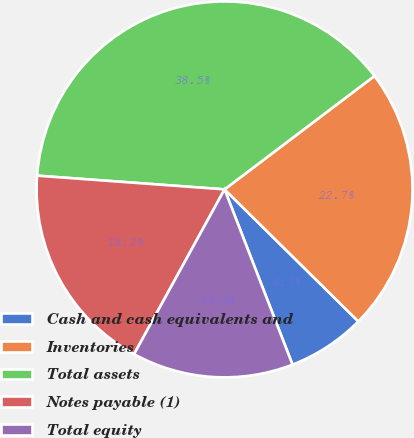Convert chart to OTSL. <chart><loc_0><loc_0><loc_500><loc_500><pie_chart><fcel>Cash and cash equivalents and<fcel>Inventories<fcel>Total assets<fcel>Notes payable (1)<fcel>Total equity<nl><fcel>6.72%<fcel>22.7%<fcel>38.53%<fcel>18.17%<fcel>13.88%<nl></chart> 